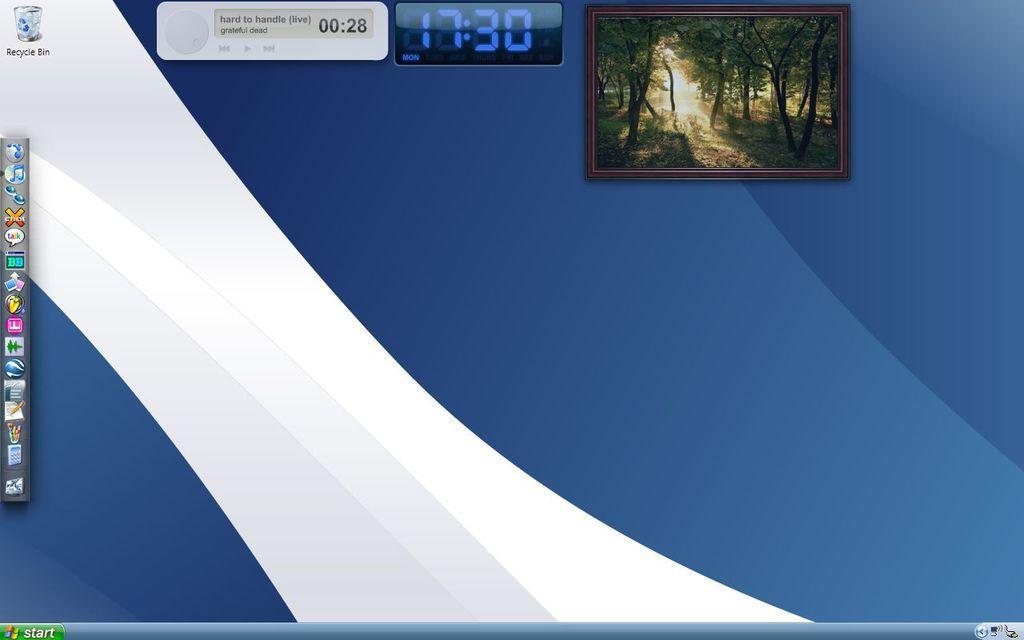Please provide a concise description of this image. This is a computer screen. On the screen there is a photo frame with trees. On the left side there are some icons. Also there is time on the top side. 